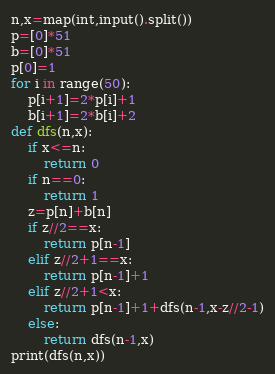Convert code to text. <code><loc_0><loc_0><loc_500><loc_500><_Python_>n,x=map(int,input().split())
p=[0]*51
b=[0]*51
p[0]=1
for i in range(50):
    p[i+1]=2*p[i]+1
    b[i+1]=2*b[i]+2
def dfs(n,x):
    if x<=n:
        return 0
    if n==0:
        return 1
    z=p[n]+b[n]
    if z//2==x:
        return p[n-1]
    elif z//2+1==x:
        return p[n-1]+1
    elif z//2+1<x:
        return p[n-1]+1+dfs(n-1,x-z//2-1)
    else:
        return dfs(n-1,x)
print(dfs(n,x))
</code> 